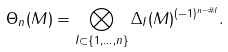<formula> <loc_0><loc_0><loc_500><loc_500>\Theta _ { n } ( M ) = \bigotimes _ { I \subset \{ 1 , \dots , n \} } \Delta _ { I } ( M ) ^ { ( - 1 ) ^ { n - \# I } } .</formula> 